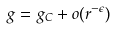Convert formula to latex. <formula><loc_0><loc_0><loc_500><loc_500>g = g _ { C } + o ( r ^ { - \epsilon } )</formula> 